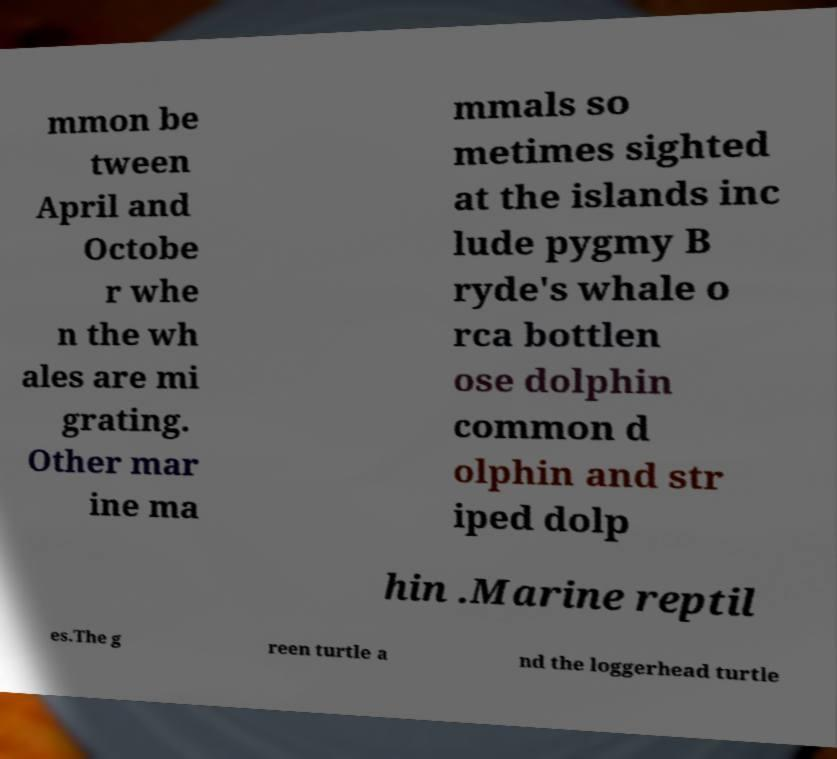What messages or text are displayed in this image? I need them in a readable, typed format. mmon be tween April and Octobe r whe n the wh ales are mi grating. Other mar ine ma mmals so metimes sighted at the islands inc lude pygmy B ryde's whale o rca bottlen ose dolphin common d olphin and str iped dolp hin .Marine reptil es.The g reen turtle a nd the loggerhead turtle 